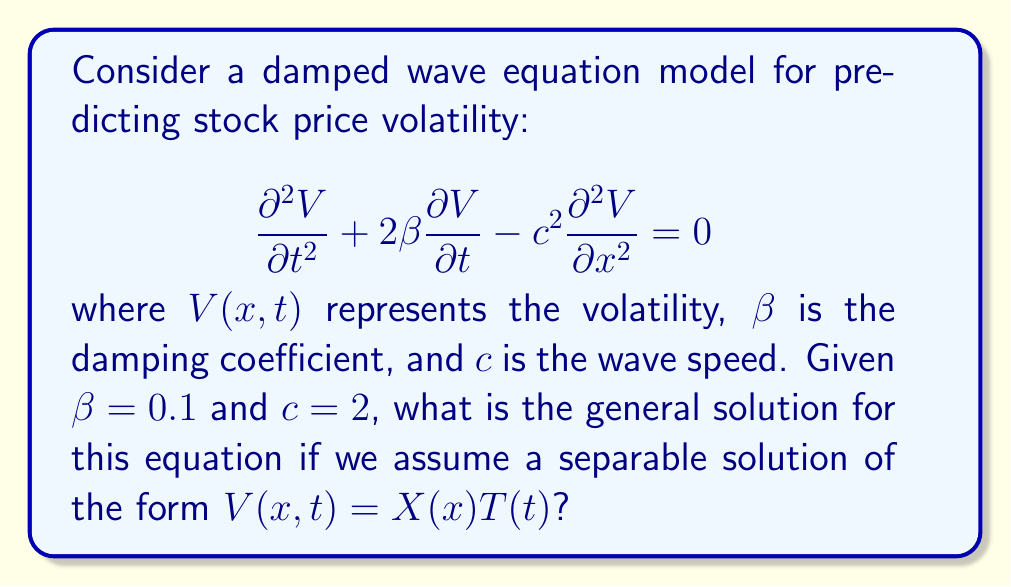Can you answer this question? Let's approach this step-by-step:

1) We assume a separable solution of the form $V(x,t) = X(x)T(t)$.

2) Substituting this into the original equation:

   $$X(x)\frac{d^2T}{dt^2} + 2\beta X(x)\frac{dT}{dt} - c^2T(t)\frac{d^2X}{dx^2} = 0$$

3) Dividing by $X(x)T(t)$:

   $$\frac{1}{T}\frac{d^2T}{dt^2} + 2\beta \frac{1}{T}\frac{dT}{dt} - c^2\frac{1}{X}\frac{d^2X}{dx^2} = 0$$

4) The left side depends only on $t$, and the right side only on $x$. For this to be true for all $x$ and $t$, both sides must equal a constant. Let's call this constant $-k^2$:

   $$\frac{1}{T}\frac{d^2T}{dt^2} + 2\beta \frac{1}{T}\frac{dT}{dt} = -k^2$$
   $$c^2\frac{1}{X}\frac{d^2X}{dx^2} = k^2$$

5) From the spatial equation:
   
   $$X(x) = A\cos(kx/c) + B\sin(kx/c)$$

6) The temporal equation is:

   $$\frac{d^2T}{dt^2} + 2\beta \frac{dT}{dt} + k^2T = 0$$

7) This is a second-order linear ODE with constant coefficients. The characteristic equation is:

   $$r^2 + 2\beta r + k^2 = 0$$

8) Solving this quadratic equation:

   $$r = -\beta \pm \sqrt{\beta^2 - k^2}$$

9) Given $\beta = 0.1$, we have three cases:

   a) If $k < 0.1$: Two distinct real roots
   b) If $k = 0.1$: One repeated real root
   c) If $k > 0.1$: Two complex conjugate roots

10) For case (c), which is most common in oscillatory systems:

    $$T(t) = e^{-\beta t}(C\cos(\omega t) + D\sin(\omega t))$$

    where $\omega = \sqrt{k^2 - \beta^2}$

11) Combining the spatial and temporal solutions:

    $$V(x,t) = e^{-\beta t}(C\cos(\omega t) + D\sin(\omega t))(A\cos(kx/c) + B\sin(kx/c))$$

This is the general solution for $k > 0.1$. For $k \leq 0.1$, the temporal part would have a different form, but the overall structure would be similar.
Answer: $V(x,t) = e^{-0.1t}(C\cos(\sqrt{k^2 - 0.01}t) + D\sin(\sqrt{k^2 - 0.01}t))(A\cos(kx/2) + B\sin(kx/2))$, where $k > 0.1$ 